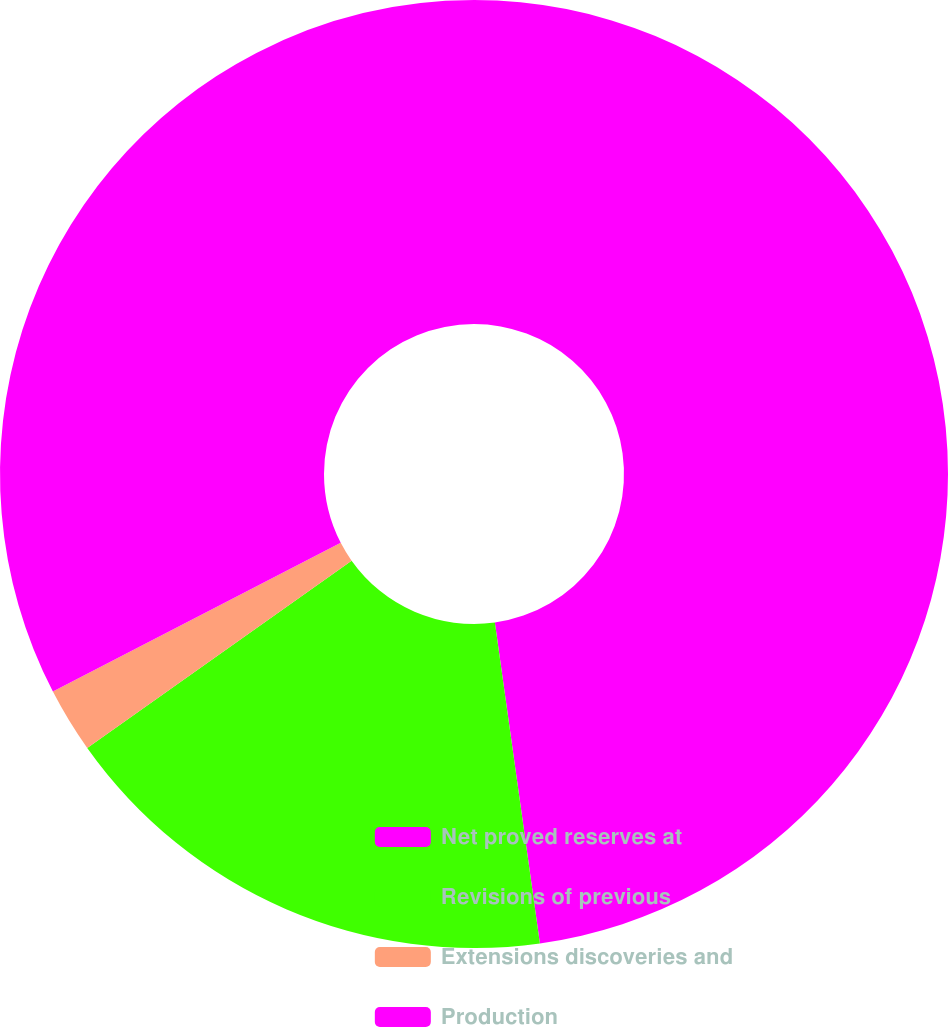<chart> <loc_0><loc_0><loc_500><loc_500><pie_chart><fcel>Net proved reserves at<fcel>Revisions of previous<fcel>Extensions discoveries and<fcel>Production<nl><fcel>47.78%<fcel>17.41%<fcel>2.22%<fcel>32.59%<nl></chart> 